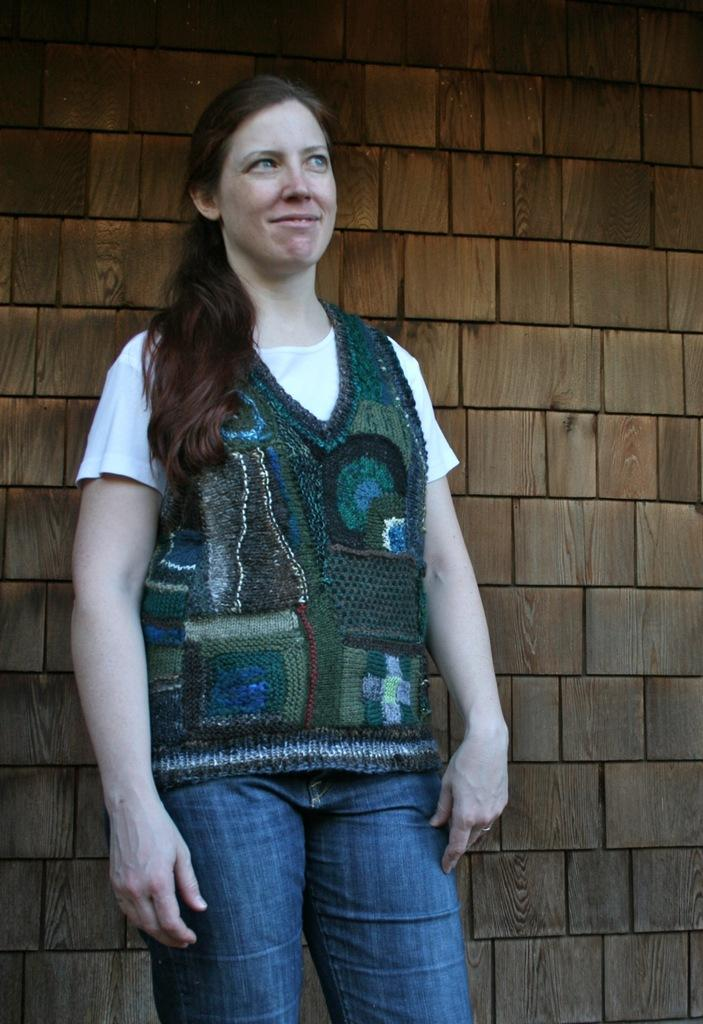Who is present in the image? There is a woman in the image. What is the woman doing in the image? The woman is standing and smiling. What can be seen in the background of the image? There is a wooden brick wall in the background of the image. What purpose does the leaf serve in the image? There is no leaf present in the image, so it cannot serve any purpose. 